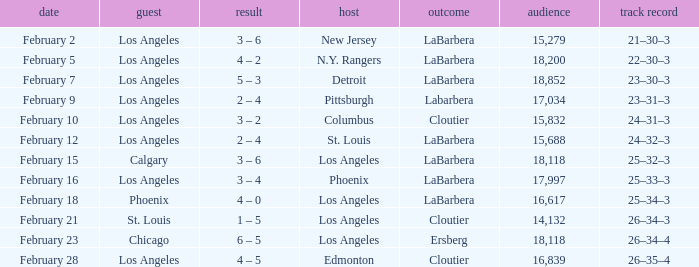What was the decision of the Kings game when Chicago was the visiting team? Ersberg. 